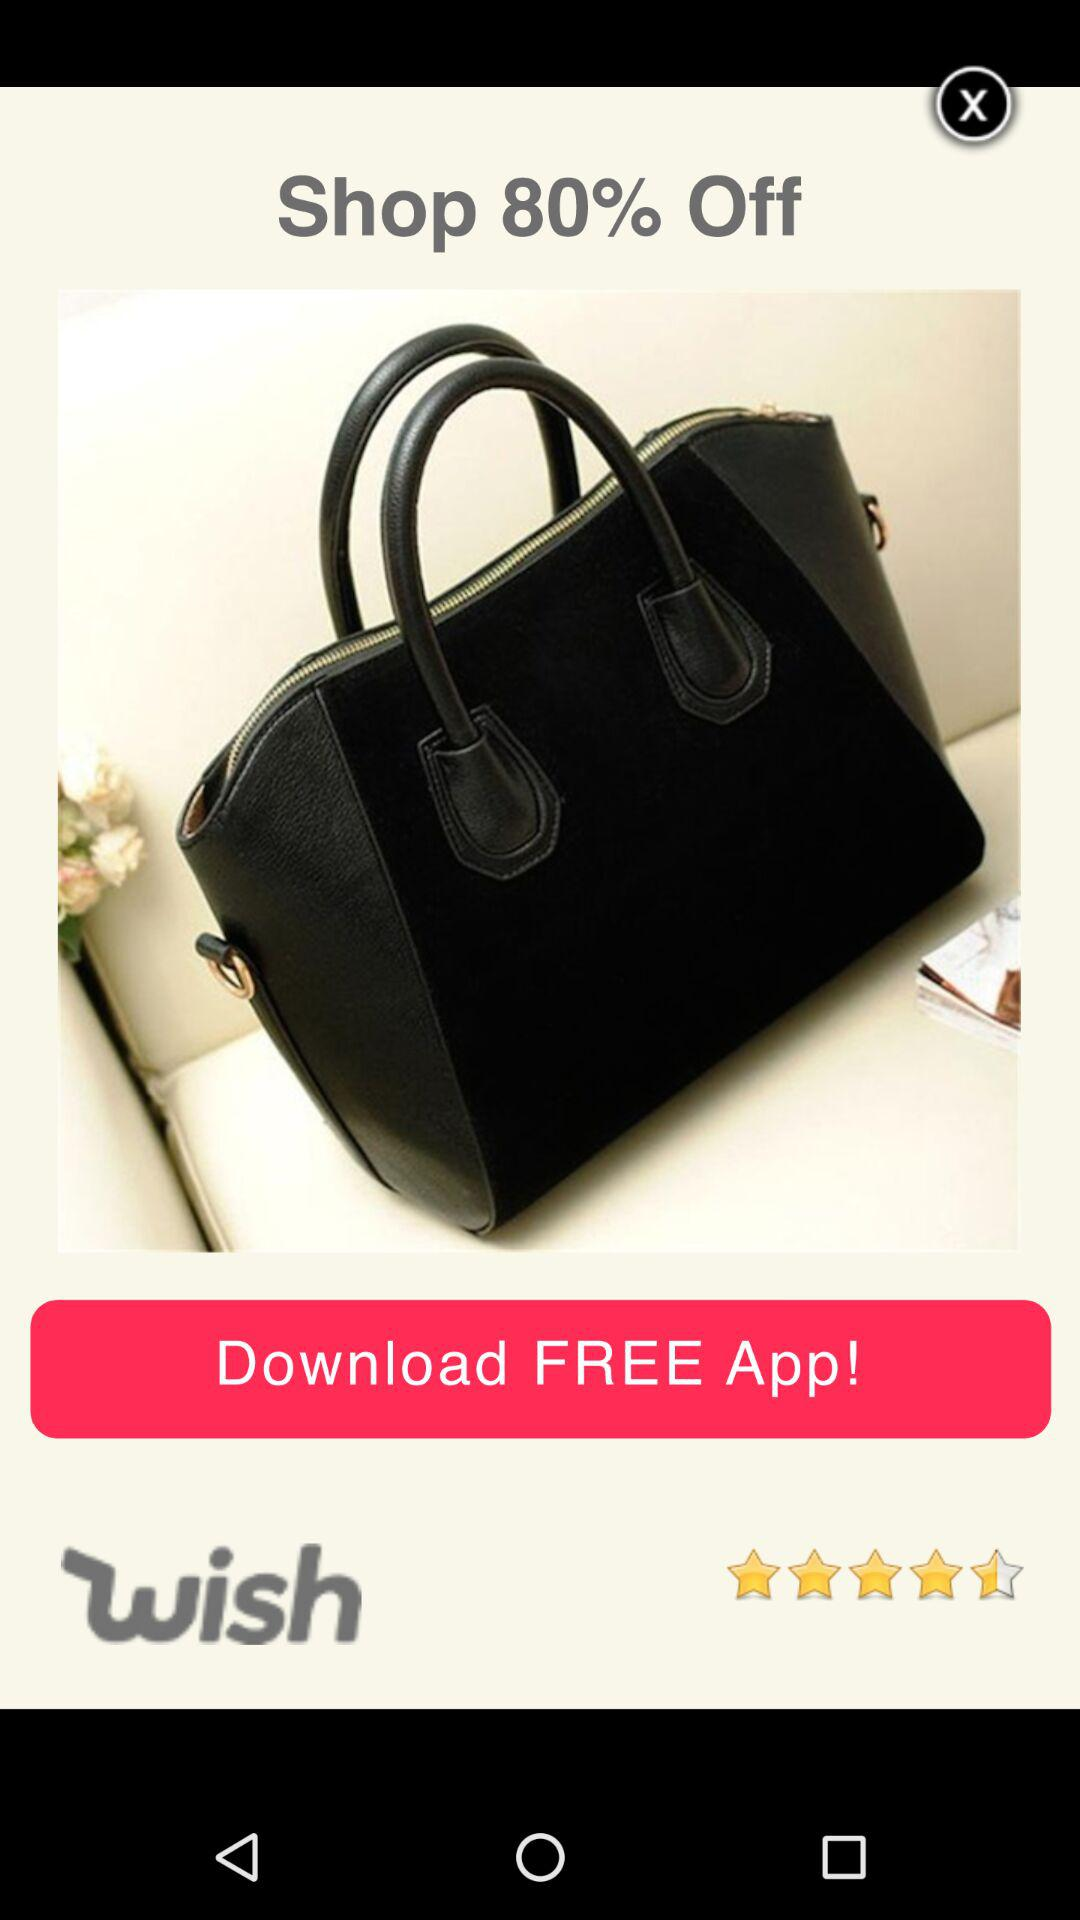What is the name of this product?
When the provided information is insufficient, respond with <no answer>. <no answer> 